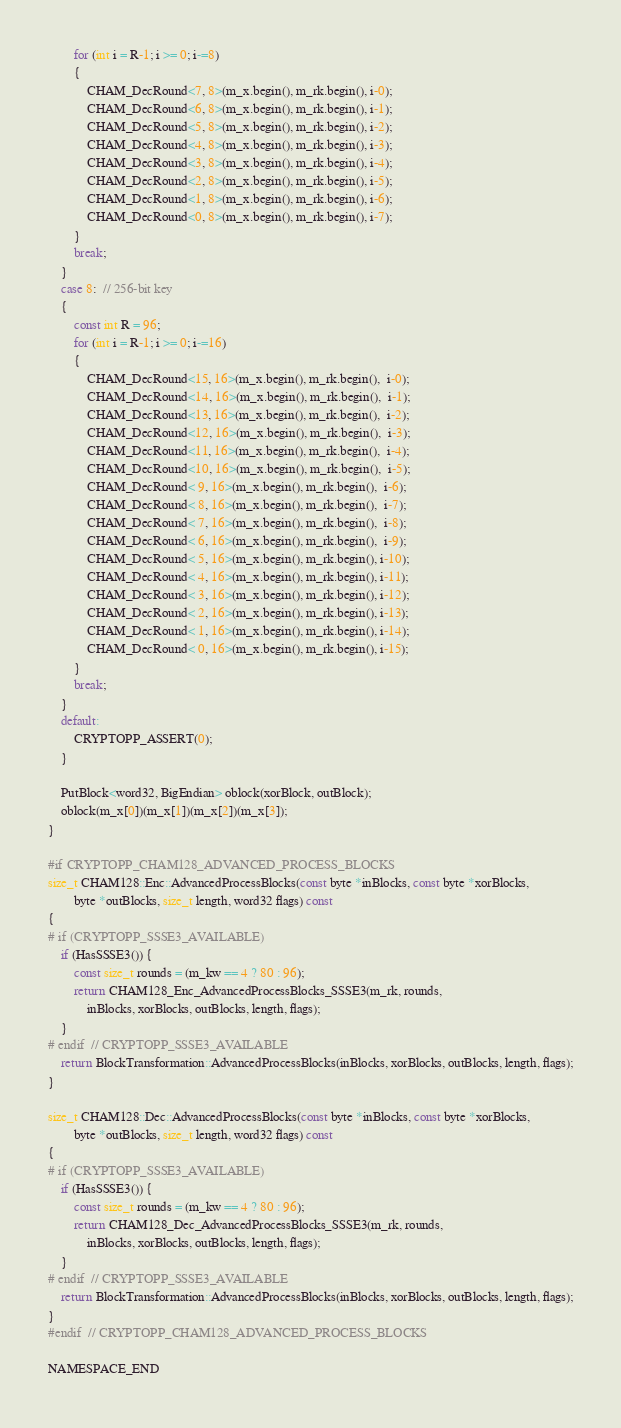Convert code to text. <code><loc_0><loc_0><loc_500><loc_500><_C++_>        for (int i = R-1; i >= 0; i-=8)
        {
            CHAM_DecRound<7, 8>(m_x.begin(), m_rk.begin(), i-0);
            CHAM_DecRound<6, 8>(m_x.begin(), m_rk.begin(), i-1);
            CHAM_DecRound<5, 8>(m_x.begin(), m_rk.begin(), i-2);
            CHAM_DecRound<4, 8>(m_x.begin(), m_rk.begin(), i-3);
            CHAM_DecRound<3, 8>(m_x.begin(), m_rk.begin(), i-4);
            CHAM_DecRound<2, 8>(m_x.begin(), m_rk.begin(), i-5);
            CHAM_DecRound<1, 8>(m_x.begin(), m_rk.begin(), i-6);
            CHAM_DecRound<0, 8>(m_x.begin(), m_rk.begin(), i-7);
        }
        break;
    }
    case 8:  // 256-bit key
    {
        const int R = 96;
        for (int i = R-1; i >= 0; i-=16)
        {
            CHAM_DecRound<15, 16>(m_x.begin(), m_rk.begin(),  i-0);
            CHAM_DecRound<14, 16>(m_x.begin(), m_rk.begin(),  i-1);
            CHAM_DecRound<13, 16>(m_x.begin(), m_rk.begin(),  i-2);
            CHAM_DecRound<12, 16>(m_x.begin(), m_rk.begin(),  i-3);
            CHAM_DecRound<11, 16>(m_x.begin(), m_rk.begin(),  i-4);
            CHAM_DecRound<10, 16>(m_x.begin(), m_rk.begin(),  i-5);
            CHAM_DecRound< 9, 16>(m_x.begin(), m_rk.begin(),  i-6);
            CHAM_DecRound< 8, 16>(m_x.begin(), m_rk.begin(),  i-7);
            CHAM_DecRound< 7, 16>(m_x.begin(), m_rk.begin(),  i-8);
            CHAM_DecRound< 6, 16>(m_x.begin(), m_rk.begin(),  i-9);
            CHAM_DecRound< 5, 16>(m_x.begin(), m_rk.begin(), i-10);
            CHAM_DecRound< 4, 16>(m_x.begin(), m_rk.begin(), i-11);
            CHAM_DecRound< 3, 16>(m_x.begin(), m_rk.begin(), i-12);
            CHAM_DecRound< 2, 16>(m_x.begin(), m_rk.begin(), i-13);
            CHAM_DecRound< 1, 16>(m_x.begin(), m_rk.begin(), i-14);
            CHAM_DecRound< 0, 16>(m_x.begin(), m_rk.begin(), i-15);
        }
        break;
    }
    default:
        CRYPTOPP_ASSERT(0);
    }

    PutBlock<word32, BigEndian> oblock(xorBlock, outBlock);
    oblock(m_x[0])(m_x[1])(m_x[2])(m_x[3]);
}

#if CRYPTOPP_CHAM128_ADVANCED_PROCESS_BLOCKS
size_t CHAM128::Enc::AdvancedProcessBlocks(const byte *inBlocks, const byte *xorBlocks,
        byte *outBlocks, size_t length, word32 flags) const
{
# if (CRYPTOPP_SSSE3_AVAILABLE)
    if (HasSSSE3()) {
        const size_t rounds = (m_kw == 4 ? 80 : 96);
        return CHAM128_Enc_AdvancedProcessBlocks_SSSE3(m_rk, rounds,
            inBlocks, xorBlocks, outBlocks, length, flags);
    }
# endif  // CRYPTOPP_SSSE3_AVAILABLE
    return BlockTransformation::AdvancedProcessBlocks(inBlocks, xorBlocks, outBlocks, length, flags);
}

size_t CHAM128::Dec::AdvancedProcessBlocks(const byte *inBlocks, const byte *xorBlocks,
        byte *outBlocks, size_t length, word32 flags) const
{
# if (CRYPTOPP_SSSE3_AVAILABLE)
    if (HasSSSE3()) {
        const size_t rounds = (m_kw == 4 ? 80 : 96);
        return CHAM128_Dec_AdvancedProcessBlocks_SSSE3(m_rk, rounds,
            inBlocks, xorBlocks, outBlocks, length, flags);
    }
# endif  // CRYPTOPP_SSSE3_AVAILABLE
    return BlockTransformation::AdvancedProcessBlocks(inBlocks, xorBlocks, outBlocks, length, flags);
}
#endif  // CRYPTOPP_CHAM128_ADVANCED_PROCESS_BLOCKS

NAMESPACE_END
</code> 